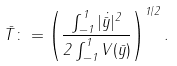<formula> <loc_0><loc_0><loc_500><loc_500>\bar { T } \colon = \left ( \frac { \int _ { - 1 } ^ { 1 } | \dot { \bar { y } } | ^ { 2 } } { 2 \int _ { - 1 } ^ { 1 } V ( \bar { y } ) } \right ) ^ { 1 / 2 } .</formula> 